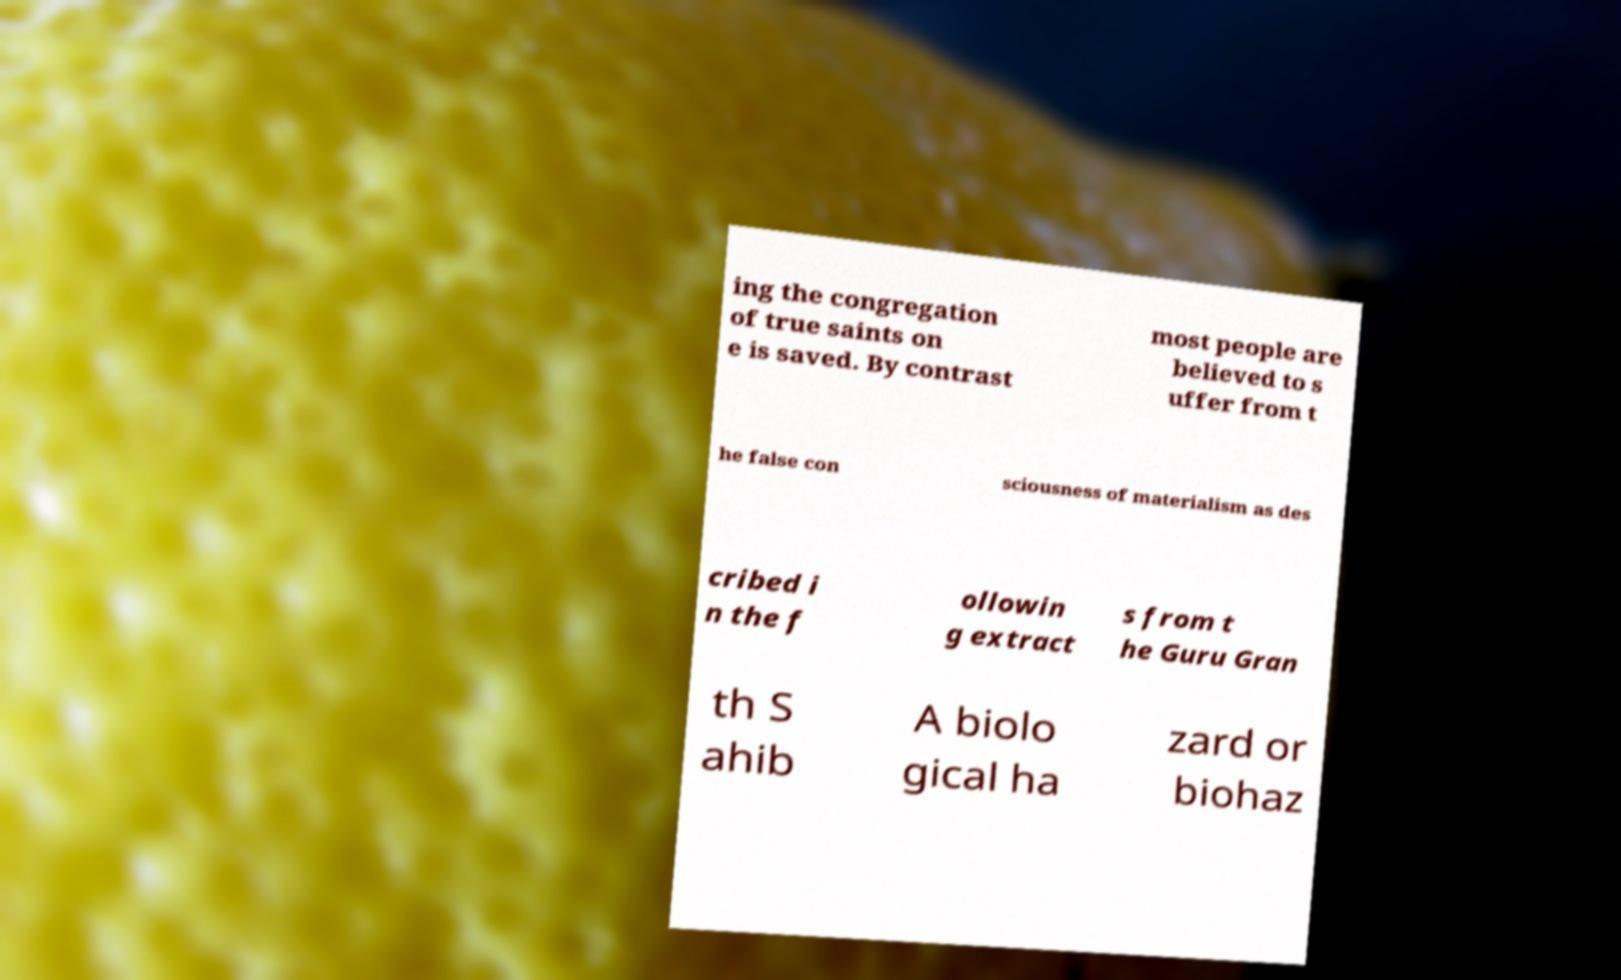There's text embedded in this image that I need extracted. Can you transcribe it verbatim? ing the congregation of true saints on e is saved. By contrast most people are believed to s uffer from t he false con sciousness of materialism as des cribed i n the f ollowin g extract s from t he Guru Gran th S ahib A biolo gical ha zard or biohaz 